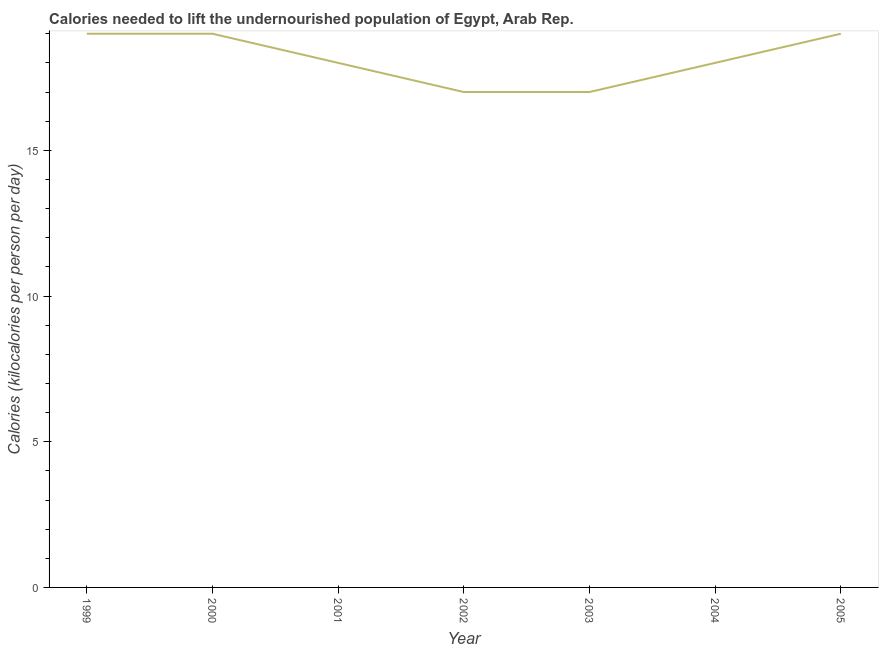What is the depth of food deficit in 2005?
Offer a very short reply. 19. Across all years, what is the maximum depth of food deficit?
Offer a very short reply. 19. Across all years, what is the minimum depth of food deficit?
Give a very brief answer. 17. In which year was the depth of food deficit minimum?
Give a very brief answer. 2002. What is the sum of the depth of food deficit?
Your response must be concise. 127. What is the average depth of food deficit per year?
Keep it short and to the point. 18.14. What is the median depth of food deficit?
Offer a very short reply. 18. What is the ratio of the depth of food deficit in 2001 to that in 2005?
Keep it short and to the point. 0.95. What is the difference between the highest and the second highest depth of food deficit?
Offer a terse response. 0. What is the difference between the highest and the lowest depth of food deficit?
Keep it short and to the point. 2. In how many years, is the depth of food deficit greater than the average depth of food deficit taken over all years?
Provide a short and direct response. 3. How many lines are there?
Provide a succinct answer. 1. How many years are there in the graph?
Offer a terse response. 7. What is the difference between two consecutive major ticks on the Y-axis?
Ensure brevity in your answer.  5. Does the graph contain grids?
Your response must be concise. No. What is the title of the graph?
Your response must be concise. Calories needed to lift the undernourished population of Egypt, Arab Rep. What is the label or title of the X-axis?
Your answer should be very brief. Year. What is the label or title of the Y-axis?
Offer a terse response. Calories (kilocalories per person per day). What is the Calories (kilocalories per person per day) in 2000?
Make the answer very short. 19. What is the Calories (kilocalories per person per day) of 2001?
Your answer should be very brief. 18. What is the Calories (kilocalories per person per day) of 2003?
Your answer should be very brief. 17. What is the Calories (kilocalories per person per day) of 2004?
Offer a terse response. 18. What is the difference between the Calories (kilocalories per person per day) in 1999 and 2000?
Your answer should be compact. 0. What is the difference between the Calories (kilocalories per person per day) in 1999 and 2002?
Your answer should be compact. 2. What is the difference between the Calories (kilocalories per person per day) in 1999 and 2005?
Provide a succinct answer. 0. What is the difference between the Calories (kilocalories per person per day) in 2000 and 2003?
Offer a terse response. 2. What is the difference between the Calories (kilocalories per person per day) in 2000 and 2005?
Your answer should be compact. 0. What is the difference between the Calories (kilocalories per person per day) in 2001 and 2002?
Offer a very short reply. 1. What is the difference between the Calories (kilocalories per person per day) in 2001 and 2004?
Your answer should be compact. 0. What is the difference between the Calories (kilocalories per person per day) in 2002 and 2003?
Your answer should be very brief. 0. What is the difference between the Calories (kilocalories per person per day) in 2002 and 2004?
Your response must be concise. -1. What is the difference between the Calories (kilocalories per person per day) in 2002 and 2005?
Your answer should be compact. -2. What is the difference between the Calories (kilocalories per person per day) in 2003 and 2005?
Your answer should be compact. -2. What is the ratio of the Calories (kilocalories per person per day) in 1999 to that in 2001?
Make the answer very short. 1.06. What is the ratio of the Calories (kilocalories per person per day) in 1999 to that in 2002?
Offer a terse response. 1.12. What is the ratio of the Calories (kilocalories per person per day) in 1999 to that in 2003?
Keep it short and to the point. 1.12. What is the ratio of the Calories (kilocalories per person per day) in 1999 to that in 2004?
Provide a short and direct response. 1.06. What is the ratio of the Calories (kilocalories per person per day) in 1999 to that in 2005?
Provide a succinct answer. 1. What is the ratio of the Calories (kilocalories per person per day) in 2000 to that in 2001?
Provide a succinct answer. 1.06. What is the ratio of the Calories (kilocalories per person per day) in 2000 to that in 2002?
Offer a terse response. 1.12. What is the ratio of the Calories (kilocalories per person per day) in 2000 to that in 2003?
Offer a very short reply. 1.12. What is the ratio of the Calories (kilocalories per person per day) in 2000 to that in 2004?
Your answer should be very brief. 1.06. What is the ratio of the Calories (kilocalories per person per day) in 2000 to that in 2005?
Ensure brevity in your answer.  1. What is the ratio of the Calories (kilocalories per person per day) in 2001 to that in 2002?
Your answer should be compact. 1.06. What is the ratio of the Calories (kilocalories per person per day) in 2001 to that in 2003?
Ensure brevity in your answer.  1.06. What is the ratio of the Calories (kilocalories per person per day) in 2001 to that in 2004?
Provide a succinct answer. 1. What is the ratio of the Calories (kilocalories per person per day) in 2001 to that in 2005?
Your answer should be compact. 0.95. What is the ratio of the Calories (kilocalories per person per day) in 2002 to that in 2004?
Offer a very short reply. 0.94. What is the ratio of the Calories (kilocalories per person per day) in 2002 to that in 2005?
Provide a short and direct response. 0.9. What is the ratio of the Calories (kilocalories per person per day) in 2003 to that in 2004?
Make the answer very short. 0.94. What is the ratio of the Calories (kilocalories per person per day) in 2003 to that in 2005?
Give a very brief answer. 0.9. What is the ratio of the Calories (kilocalories per person per day) in 2004 to that in 2005?
Your answer should be compact. 0.95. 